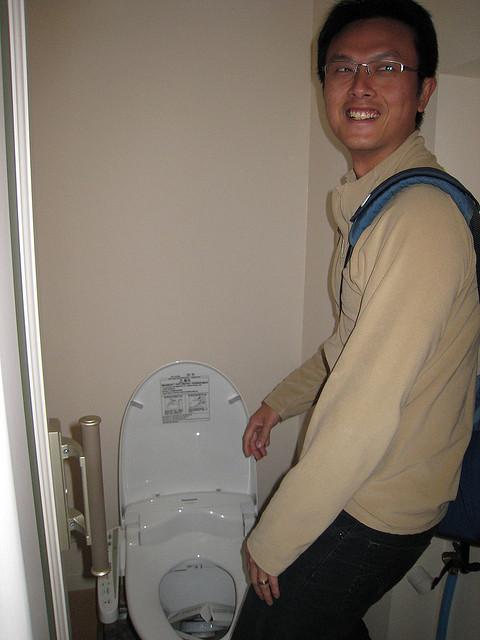What is the man ready to do next?
From the following four choices, select the correct answer to address the question.
Options: Flush, throw, rinse, burn. Flush. 